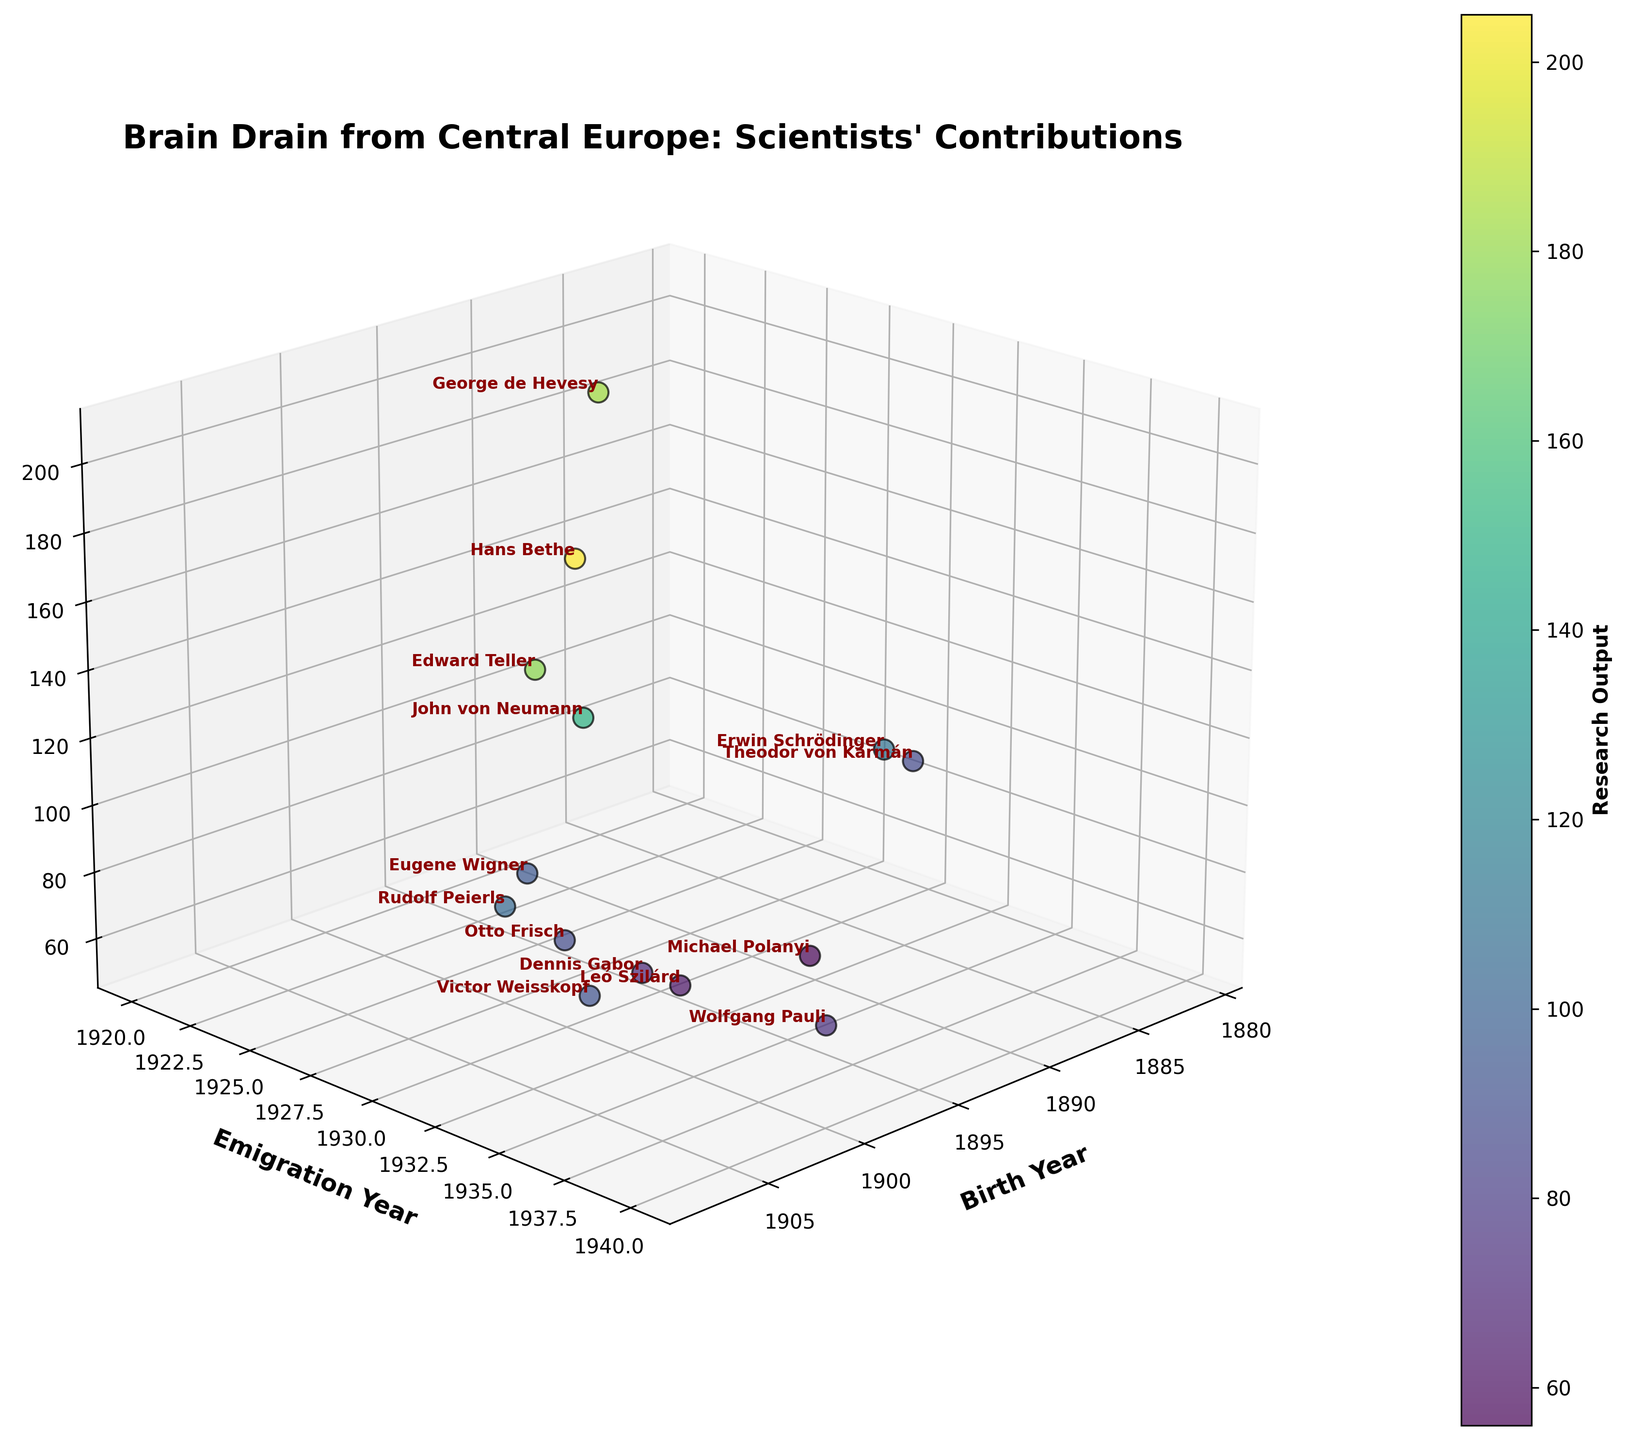What is the title of the figure? The title is usually displayed at the top of the figure. In this case, it is specified in the code as "Brain Drain from Central Europe: Scientists' Contributions".
Answer: Brain Drain from Central Europe: Scientists' Contributions How many scientists are represented in the figure? Each data point in the plot corresponds to a scientist. By counting all the data points or checking the number of names listed in the data, we can determine the total number of scientists.
Answer: 14 Which scientist has the highest research output? The color bar and the z-axis represent research output. By checking which data point corresponds to the highest z-axis value and its associated name, we find the scientist with the highest research output.
Answer: Hans Bethe What is the range of birth years for the scientists? The x-axis represents the birth years. By observing the smallest and largest values on the x-axis, we can determine the range of birth years.
Answer: 1881 to 1908 Which scientist emigrated the latest among those born in the 1900s? We first identify the names of scientists born in the 1900s from the x-axis. Next, we find the one with the most recent emigration year on the y-axis.
Answer: Wolfgang Pauli (1940) What is the median research output value plotted? To find the median research output, we must list all research output values in ascending order and identify the middle value. If the list has an even number of observations, the median is the average of the two middle numbers.
Answer: 87.5 Which scientists emigrated in 1933 and how do their research outputs compare? By looking at the data points corresponding to the year 1933 on the y-axis, we can identify the scientists. Then we compare their z-axis positions, or research output values.
Answer: Leó Szilárd (62), Dennis Gabor (70), John von Neumann (150), Michael Polanyi (56), Erwin Schrödinger (110), Otto Frisch (88), Rudolf Peierls (104). John von Neumann has the highest output among them Who is the scientist having the earliest birth year and what is their research output? By examining the earliest year on the x-axis (birth year) and identifying the corresponding data point and name, we can find the scientist and their research output (z-axis value).
Answer: Theodor von Kármán, 87 Which scientists have research output greater than 150? By looking at the data points along the z-axis and identifying those above the 150 mark, we can determine the names associated with those points.
Answer: Hans Bethe (205), Edward Teller (178), George de Hevesy (183), John von Neumann (150) What is the average emigration year of the scientists born after 1900? We first filter the scientists born after 1900 from the x-axis. Then, we sum their emigration years and divide by the number of those scientists to find the average. Calculation: (1930 + 1935 + 1940 + 1937 + 1935) / 5 = 1935.4.
Answer: 1935.4 